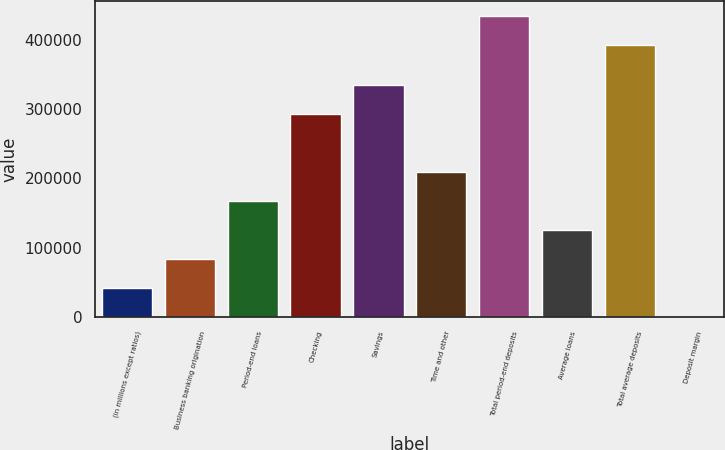Convert chart to OTSL. <chart><loc_0><loc_0><loc_500><loc_500><bar_chart><fcel>(in millions except ratios)<fcel>Business banking origination<fcel>Period-end loans<fcel>Checking<fcel>Savings<fcel>Time and other<fcel>Total period-end deposits<fcel>Average loans<fcel>Total average deposits<fcel>Deposit margin<nl><fcel>41855.2<fcel>83707.9<fcel>167413<fcel>292971<fcel>334824<fcel>209266<fcel>433948<fcel>125560<fcel>392095<fcel>2.57<nl></chart> 